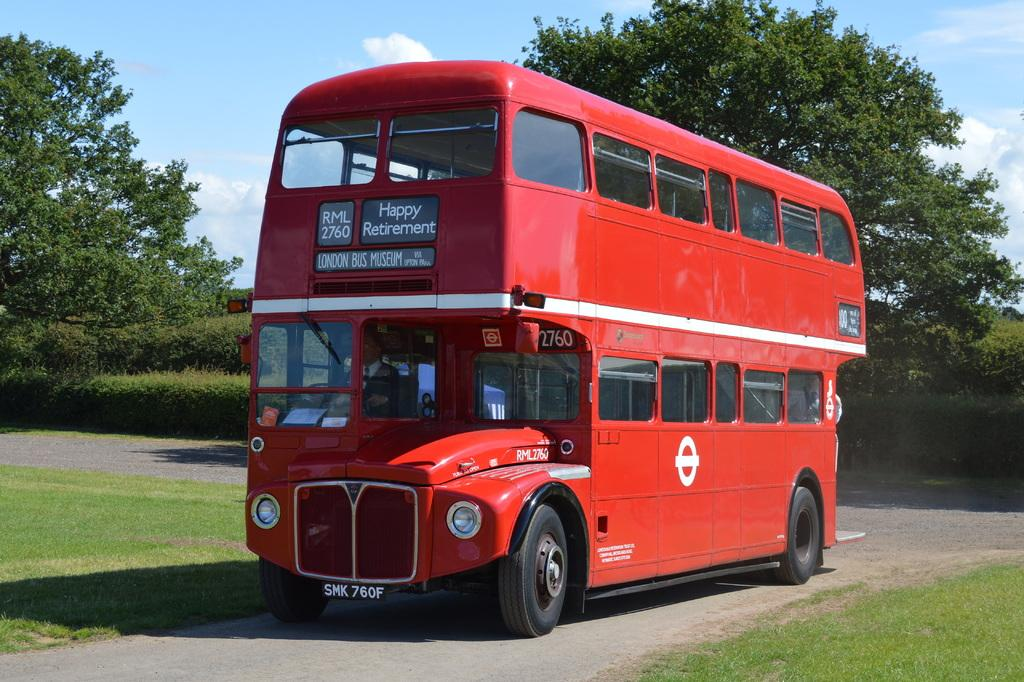Provide a one-sentence caption for the provided image. a red double decker bus from The London Bus Museum reading Happy Retirement. 